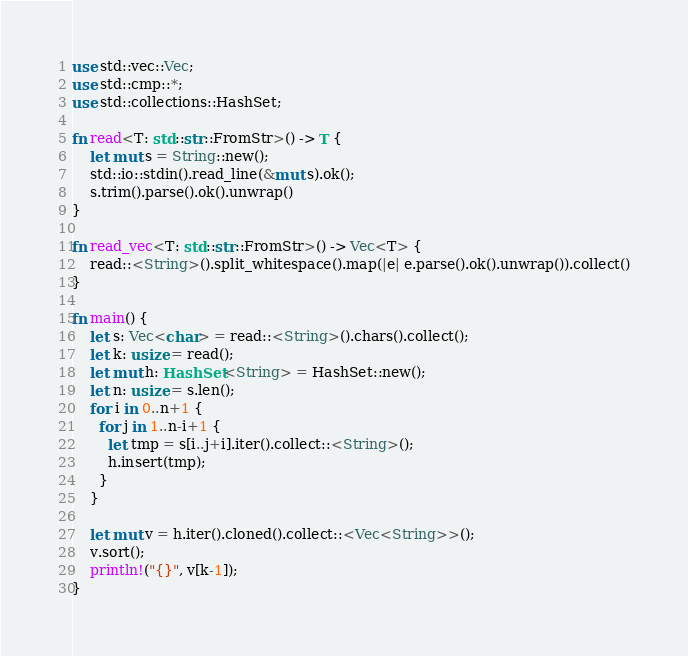Convert code to text. <code><loc_0><loc_0><loc_500><loc_500><_Rust_>use std::vec::Vec;
use std::cmp::*;
use std::collections::HashSet;

fn read<T: std::str::FromStr>() -> T {
    let mut s = String::new();
    std::io::stdin().read_line(&mut s).ok();
    s.trim().parse().ok().unwrap()
}

fn read_vec<T: std::str::FromStr>() -> Vec<T> {
    read::<String>().split_whitespace().map(|e| e.parse().ok().unwrap()).collect()
}

fn main() {
    let s: Vec<char> = read::<String>().chars().collect();
    let k: usize = read();
    let mut h: HashSet<String> = HashSet::new();
    let n: usize = s.len();
    for i in 0..n+1 {
      for j in 1..n-i+1 {
        let tmp = s[i..j+i].iter().collect::<String>();
        h.insert(tmp);
      }
    }

    let mut v = h.iter().cloned().collect::<Vec<String>>();
    v.sort();
    println!("{}", v[k-1]);
}

</code> 